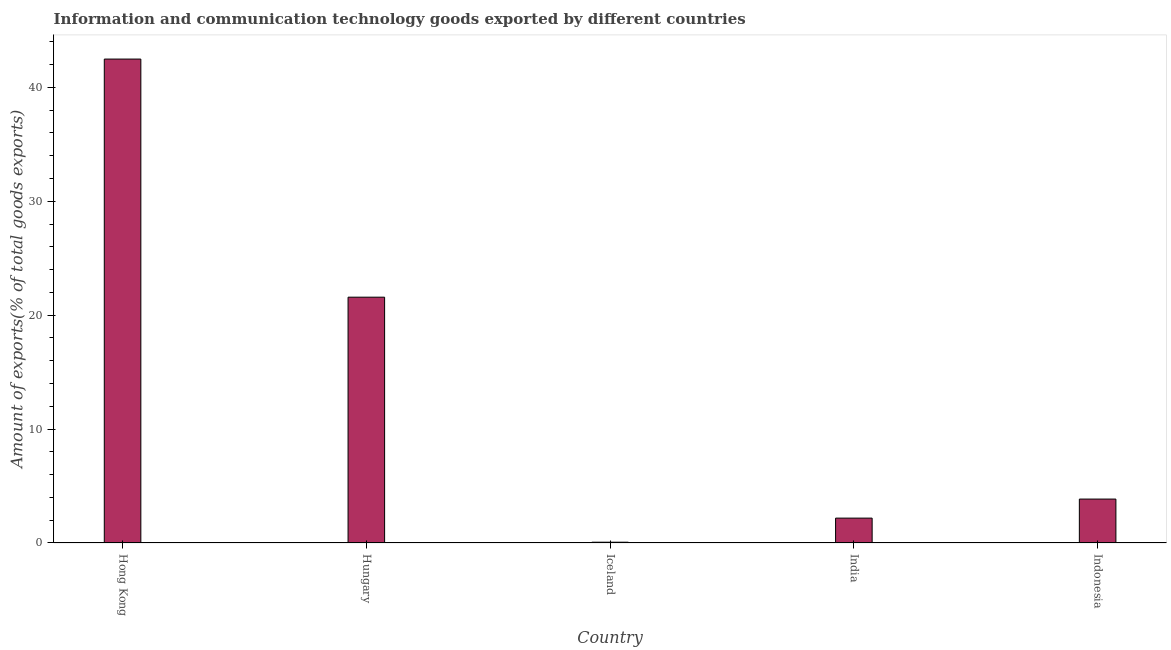Does the graph contain any zero values?
Your response must be concise. No. What is the title of the graph?
Ensure brevity in your answer.  Information and communication technology goods exported by different countries. What is the label or title of the X-axis?
Provide a succinct answer. Country. What is the label or title of the Y-axis?
Ensure brevity in your answer.  Amount of exports(% of total goods exports). What is the amount of ict goods exports in Iceland?
Offer a very short reply. 0.07. Across all countries, what is the maximum amount of ict goods exports?
Ensure brevity in your answer.  42.48. Across all countries, what is the minimum amount of ict goods exports?
Provide a short and direct response. 0.07. In which country was the amount of ict goods exports maximum?
Your answer should be very brief. Hong Kong. What is the sum of the amount of ict goods exports?
Provide a short and direct response. 70.16. What is the difference between the amount of ict goods exports in Hungary and Indonesia?
Your answer should be compact. 17.72. What is the average amount of ict goods exports per country?
Offer a terse response. 14.03. What is the median amount of ict goods exports?
Provide a succinct answer. 3.86. What is the ratio of the amount of ict goods exports in Hong Kong to that in India?
Your answer should be very brief. 19.46. What is the difference between the highest and the second highest amount of ict goods exports?
Your answer should be compact. 20.9. Is the sum of the amount of ict goods exports in Hungary and Indonesia greater than the maximum amount of ict goods exports across all countries?
Give a very brief answer. No. What is the difference between the highest and the lowest amount of ict goods exports?
Your response must be concise. 42.41. In how many countries, is the amount of ict goods exports greater than the average amount of ict goods exports taken over all countries?
Offer a terse response. 2. How many bars are there?
Give a very brief answer. 5. Are all the bars in the graph horizontal?
Provide a short and direct response. No. What is the difference between two consecutive major ticks on the Y-axis?
Give a very brief answer. 10. Are the values on the major ticks of Y-axis written in scientific E-notation?
Offer a very short reply. No. What is the Amount of exports(% of total goods exports) in Hong Kong?
Keep it short and to the point. 42.48. What is the Amount of exports(% of total goods exports) in Hungary?
Give a very brief answer. 21.58. What is the Amount of exports(% of total goods exports) in Iceland?
Your answer should be compact. 0.07. What is the Amount of exports(% of total goods exports) of India?
Offer a very short reply. 2.18. What is the Amount of exports(% of total goods exports) in Indonesia?
Ensure brevity in your answer.  3.86. What is the difference between the Amount of exports(% of total goods exports) in Hong Kong and Hungary?
Offer a terse response. 20.9. What is the difference between the Amount of exports(% of total goods exports) in Hong Kong and Iceland?
Keep it short and to the point. 42.41. What is the difference between the Amount of exports(% of total goods exports) in Hong Kong and India?
Your response must be concise. 40.3. What is the difference between the Amount of exports(% of total goods exports) in Hong Kong and Indonesia?
Your answer should be compact. 38.62. What is the difference between the Amount of exports(% of total goods exports) in Hungary and Iceland?
Keep it short and to the point. 21.51. What is the difference between the Amount of exports(% of total goods exports) in Hungary and India?
Provide a short and direct response. 19.4. What is the difference between the Amount of exports(% of total goods exports) in Hungary and Indonesia?
Offer a very short reply. 17.72. What is the difference between the Amount of exports(% of total goods exports) in Iceland and India?
Offer a terse response. -2.11. What is the difference between the Amount of exports(% of total goods exports) in Iceland and Indonesia?
Provide a succinct answer. -3.79. What is the difference between the Amount of exports(% of total goods exports) in India and Indonesia?
Offer a terse response. -1.67. What is the ratio of the Amount of exports(% of total goods exports) in Hong Kong to that in Hungary?
Provide a short and direct response. 1.97. What is the ratio of the Amount of exports(% of total goods exports) in Hong Kong to that in Iceland?
Give a very brief answer. 627.19. What is the ratio of the Amount of exports(% of total goods exports) in Hong Kong to that in India?
Keep it short and to the point. 19.46. What is the ratio of the Amount of exports(% of total goods exports) in Hong Kong to that in Indonesia?
Ensure brevity in your answer.  11.02. What is the ratio of the Amount of exports(% of total goods exports) in Hungary to that in Iceland?
Provide a succinct answer. 318.59. What is the ratio of the Amount of exports(% of total goods exports) in Hungary to that in India?
Provide a short and direct response. 9.89. What is the ratio of the Amount of exports(% of total goods exports) in Hungary to that in Indonesia?
Give a very brief answer. 5.6. What is the ratio of the Amount of exports(% of total goods exports) in Iceland to that in India?
Provide a short and direct response. 0.03. What is the ratio of the Amount of exports(% of total goods exports) in Iceland to that in Indonesia?
Your response must be concise. 0.02. What is the ratio of the Amount of exports(% of total goods exports) in India to that in Indonesia?
Make the answer very short. 0.57. 